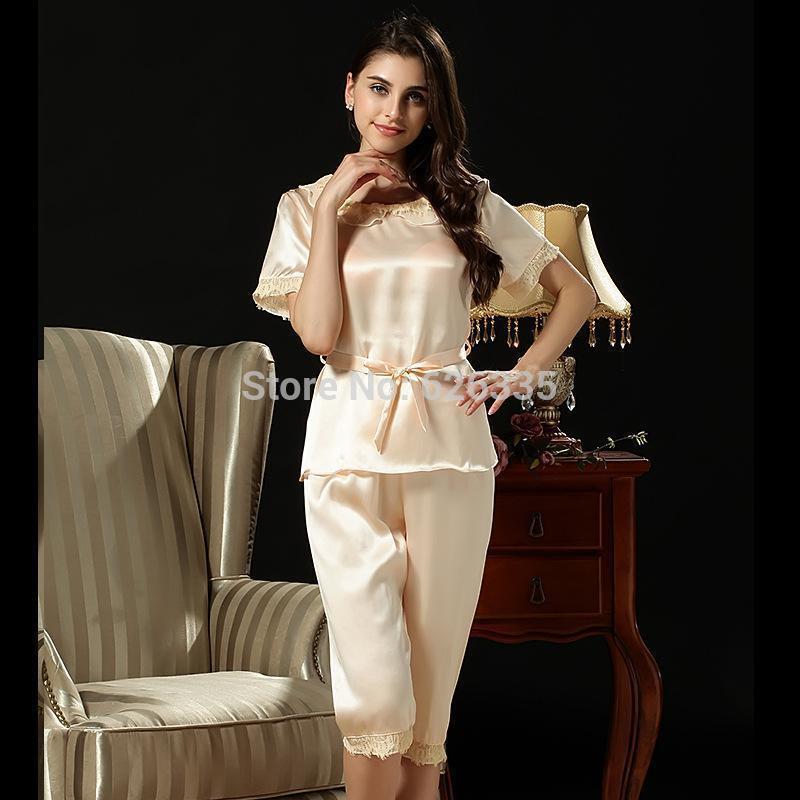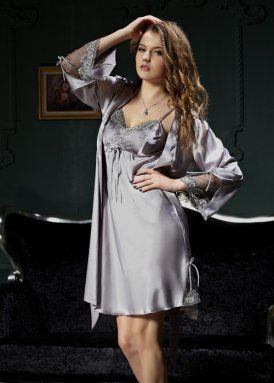The first image is the image on the left, the second image is the image on the right. Assess this claim about the two images: "Pajama pants in one image are knee length with lace edging, topped with a pajama shirt with tie belt at the waist.". Correct or not? Answer yes or no. Yes. The first image is the image on the left, the second image is the image on the right. Considering the images on both sides, is "The model on the left wears matching short-sleeve pajama top and capri-length bottoms, and the model on the right wears a robe over a spaghetti-strap gown." valid? Answer yes or no. Yes. 